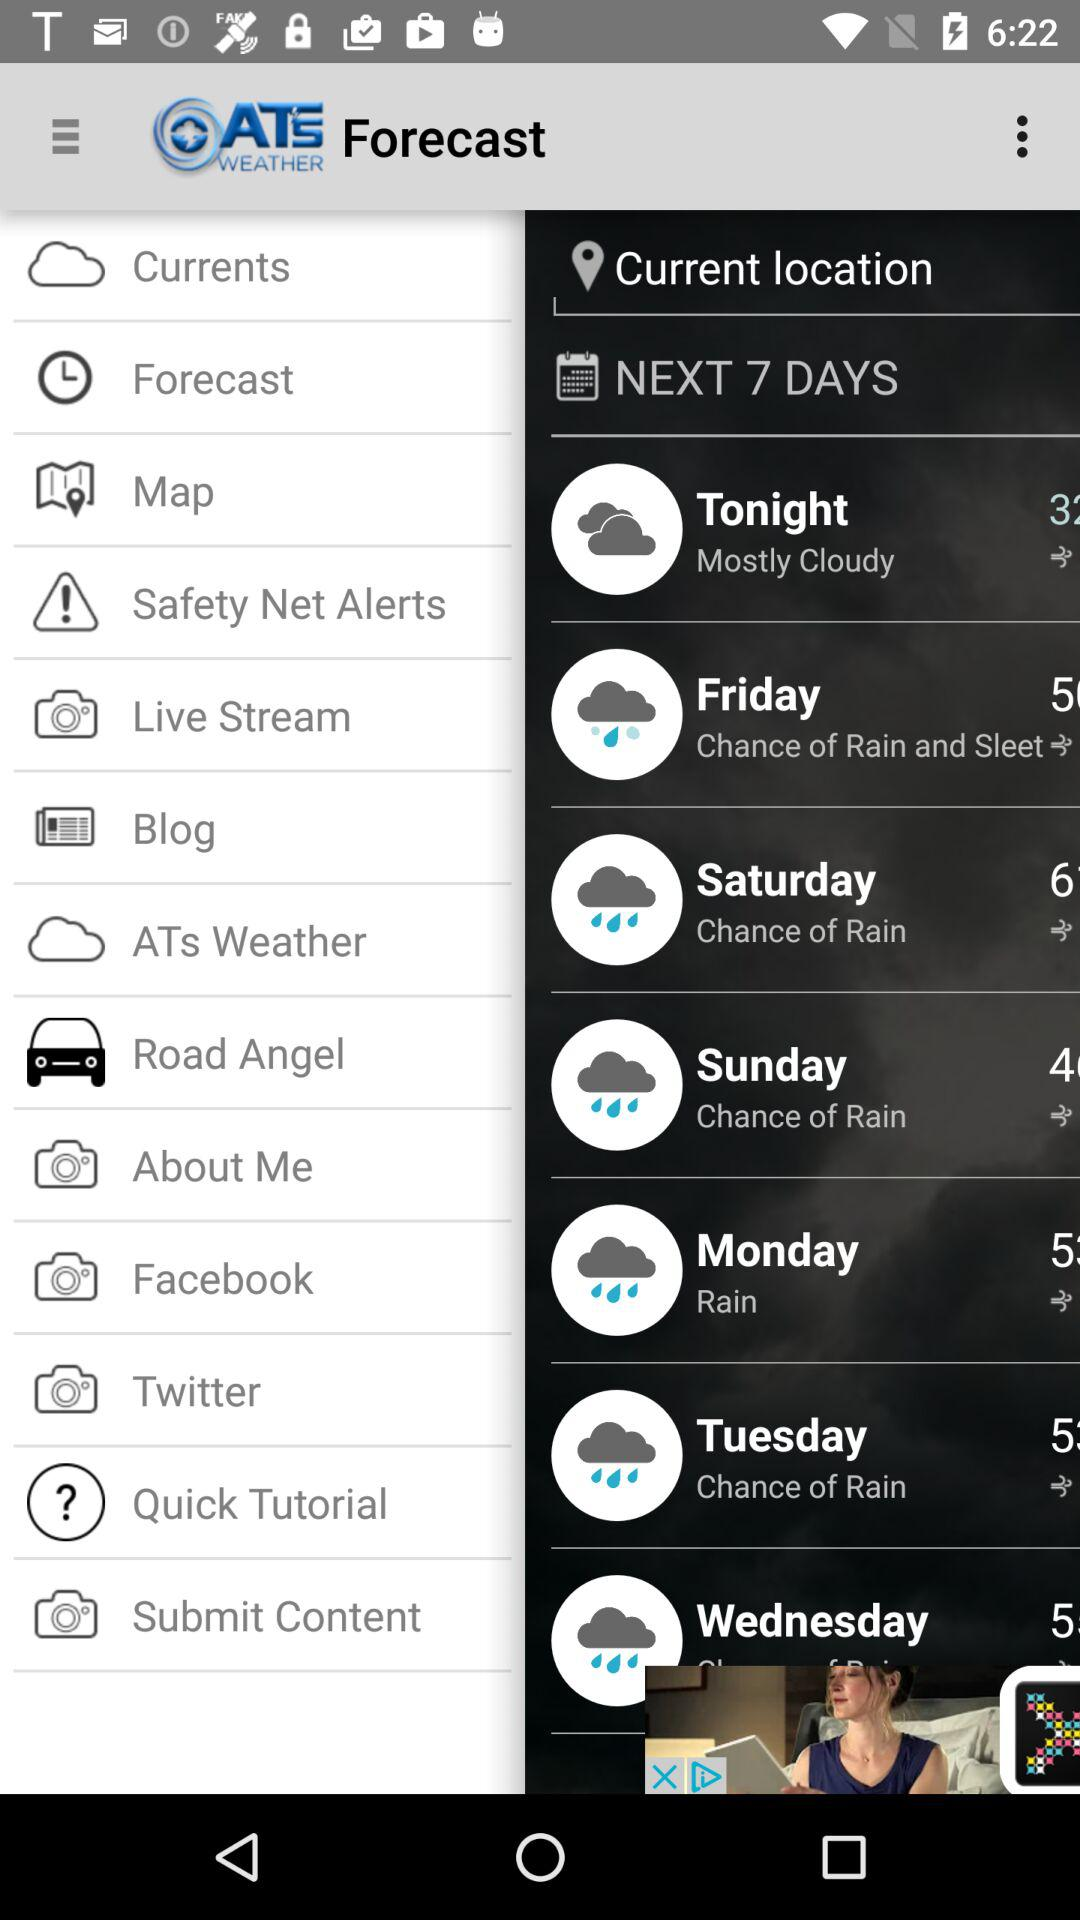What is temperature at saturday?
When the provided information is insufficient, respond with <no answer>. <no answer> 